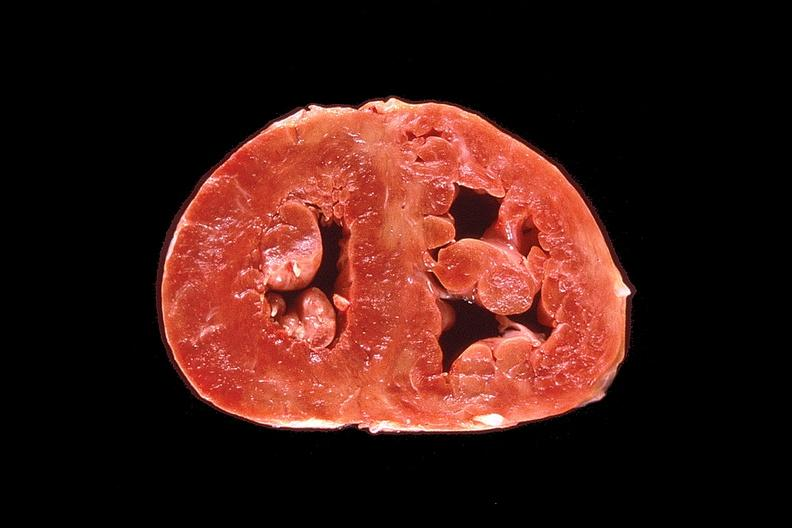where is this?
Answer the question using a single word or phrase. Heart 